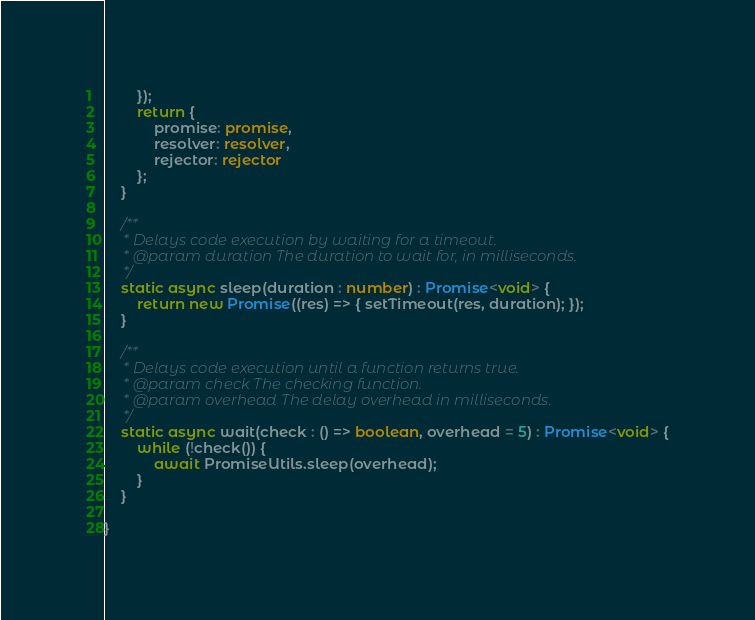<code> <loc_0><loc_0><loc_500><loc_500><_TypeScript_>        });
        return {
            promise: promise,
            resolver: resolver,
            rejector: rejector
        };
    }

    /**
     * Delays code execution by waiting for a timeout.
     * @param duration The duration to wait for, in milliseconds.
     */
    static async sleep(duration : number) : Promise<void> {
        return new Promise((res) => { setTimeout(res, duration); });
    }

    /**
     * Delays code execution until a function returns true.
     * @param check The checking function.
     * @param overhead The delay overhead in milliseconds.
     */
    static async wait(check : () => boolean, overhead = 5) : Promise<void> {
        while (!check()) {
            await PromiseUtils.sleep(overhead);
        }
    }

}</code> 